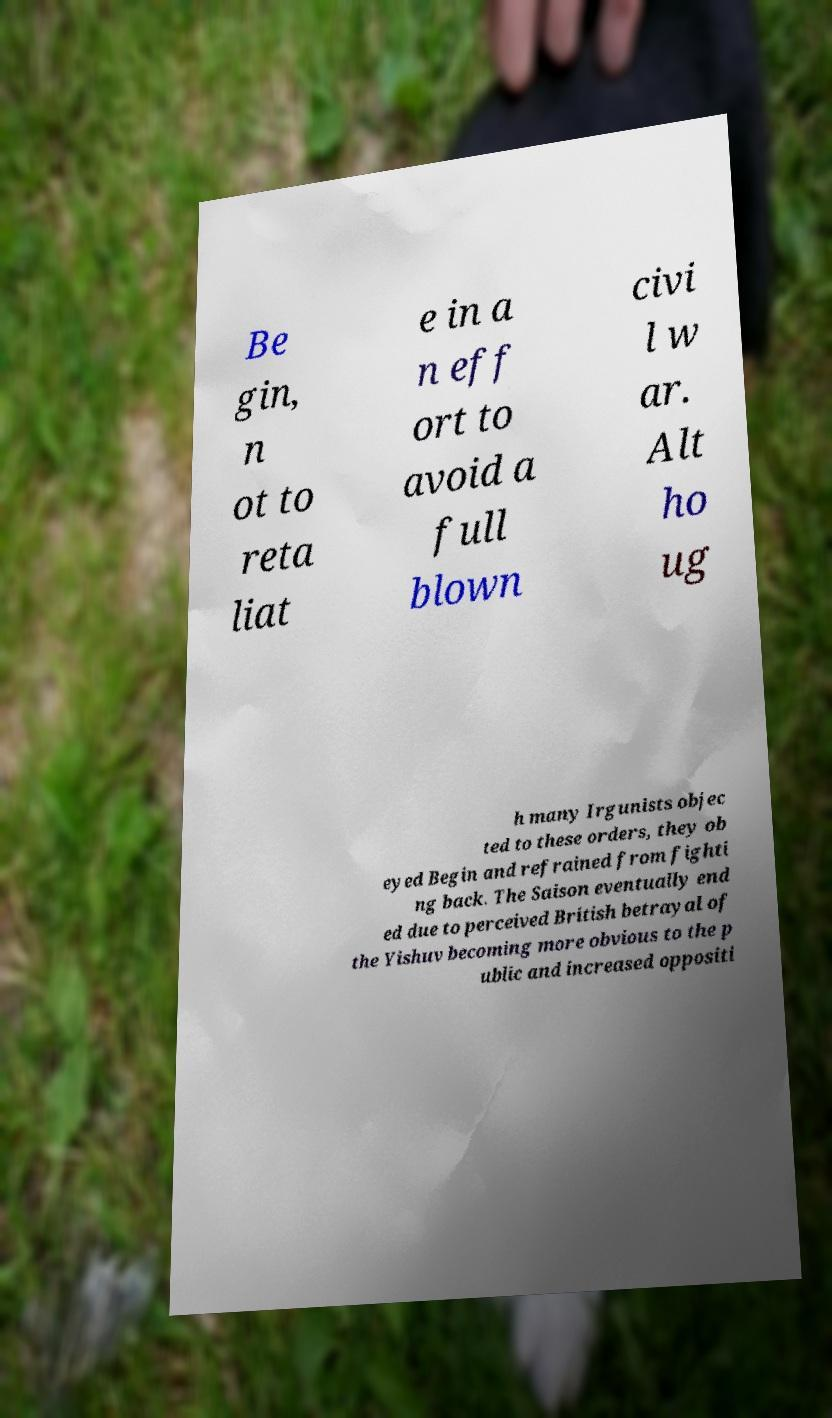What messages or text are displayed in this image? I need them in a readable, typed format. Be gin, n ot to reta liat e in a n eff ort to avoid a full blown civi l w ar. Alt ho ug h many Irgunists objec ted to these orders, they ob eyed Begin and refrained from fighti ng back. The Saison eventually end ed due to perceived British betrayal of the Yishuv becoming more obvious to the p ublic and increased oppositi 